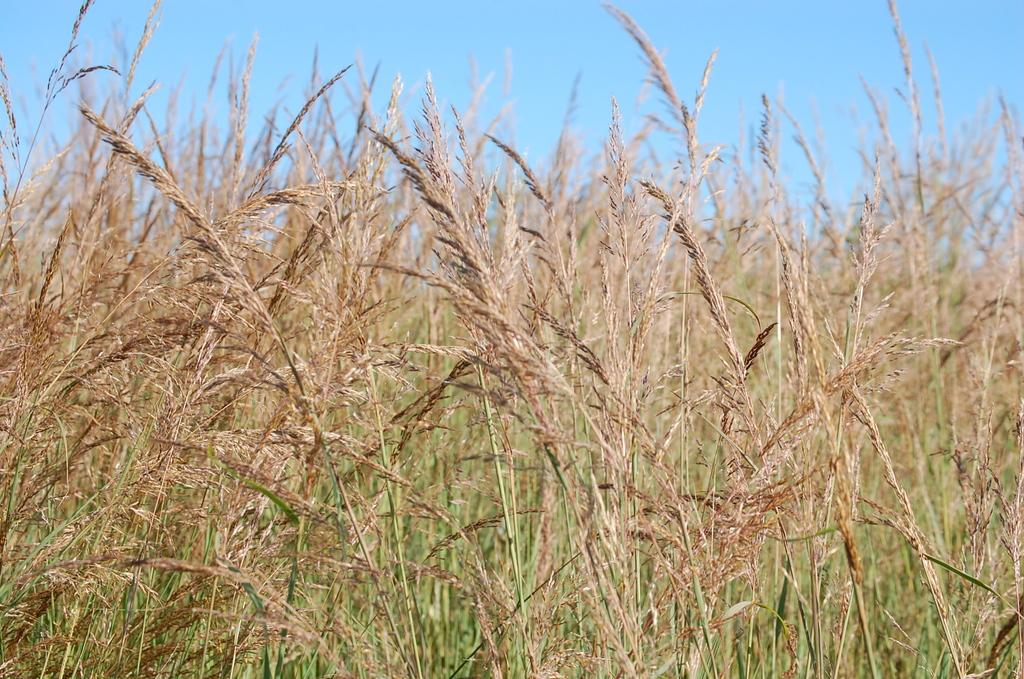What can be seen in the background of the image? The sky is visible in the image. What type of vegetation is present in the image? There is grass in the image. What type of stone can be seen in the image? There is no stone present in the image. How many beads are visible in the image? There are no beads present in the image. 